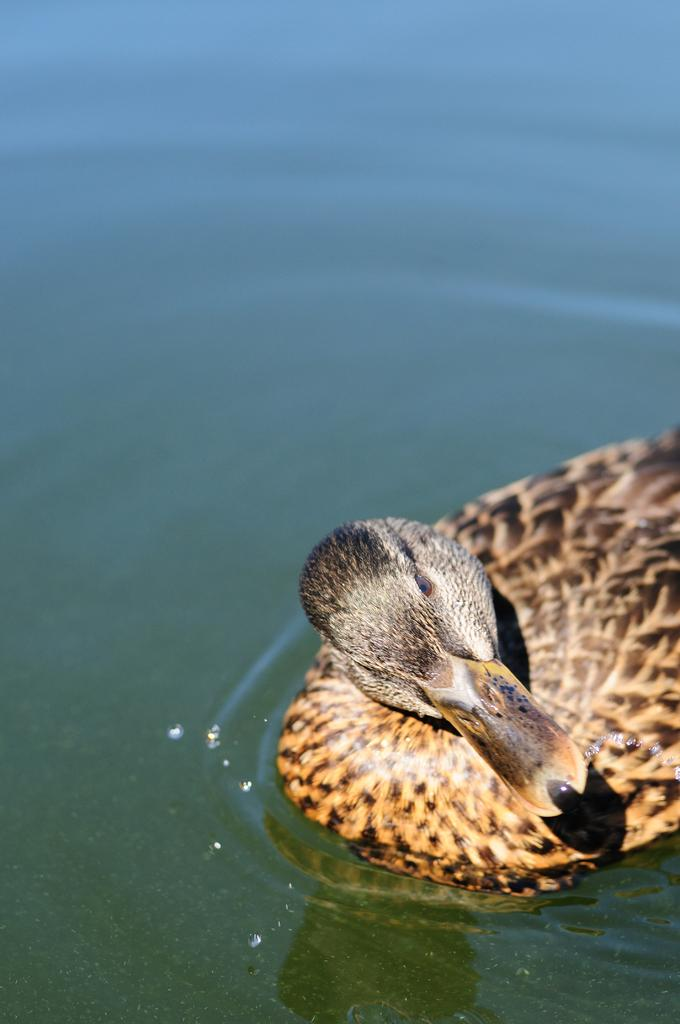What animal is present in the image? There is a duck in the image. Where is the duck located? The duck is on the water. What type of territory does the duck claim in the image? There is no indication of the duck claiming any territory in the image. 